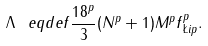<formula> <loc_0><loc_0><loc_500><loc_500>\Lambda \ e q d e f \frac { 1 8 ^ { p } } { 3 } ( N ^ { p } + 1 ) M ^ { p } \| f \| _ { \L i p } ^ { p } .</formula> 